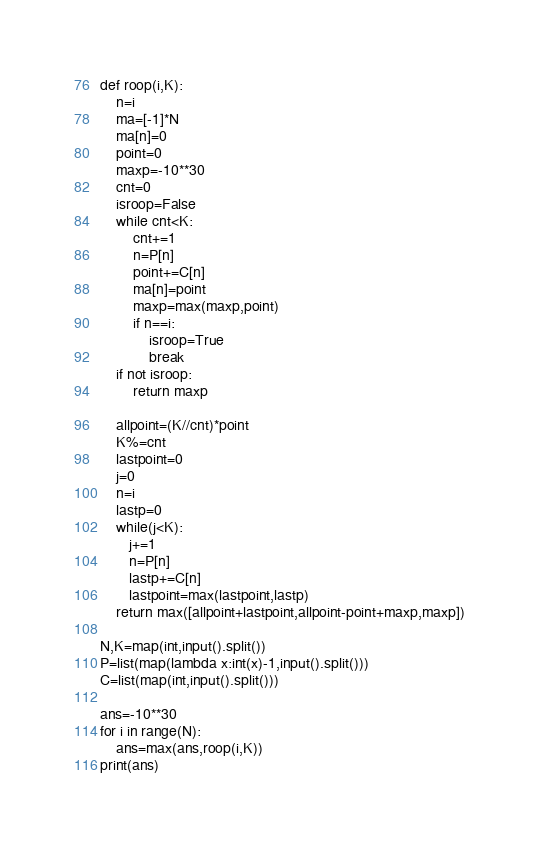<code> <loc_0><loc_0><loc_500><loc_500><_Python_>def roop(i,K):
    n=i
    ma=[-1]*N
    ma[n]=0
    point=0
    maxp=-10**30
    cnt=0
    isroop=False
    while cnt<K:
        cnt+=1
        n=P[n]
        point+=C[n]
        ma[n]=point
        maxp=max(maxp,point)
        if n==i:
            isroop=True
            break
    if not isroop:
        return maxp
    
    allpoint=(K//cnt)*point
    K%=cnt
    lastpoint=0
    j=0
    n=i
    lastp=0
    while(j<K):
       j+=1
       n=P[n]
       lastp+=C[n]
       lastpoint=max(lastpoint,lastp)
    return max([allpoint+lastpoint,allpoint-point+maxp,maxp])

N,K=map(int,input().split())
P=list(map(lambda x:int(x)-1,input().split()))
C=list(map(int,input().split()))

ans=-10**30
for i in range(N):
    ans=max(ans,roop(i,K))
print(ans)</code> 